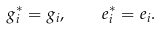<formula> <loc_0><loc_0><loc_500><loc_500>g _ { i } ^ { * } = g _ { i } , \quad e _ { i } ^ { * } = e _ { i } .</formula> 